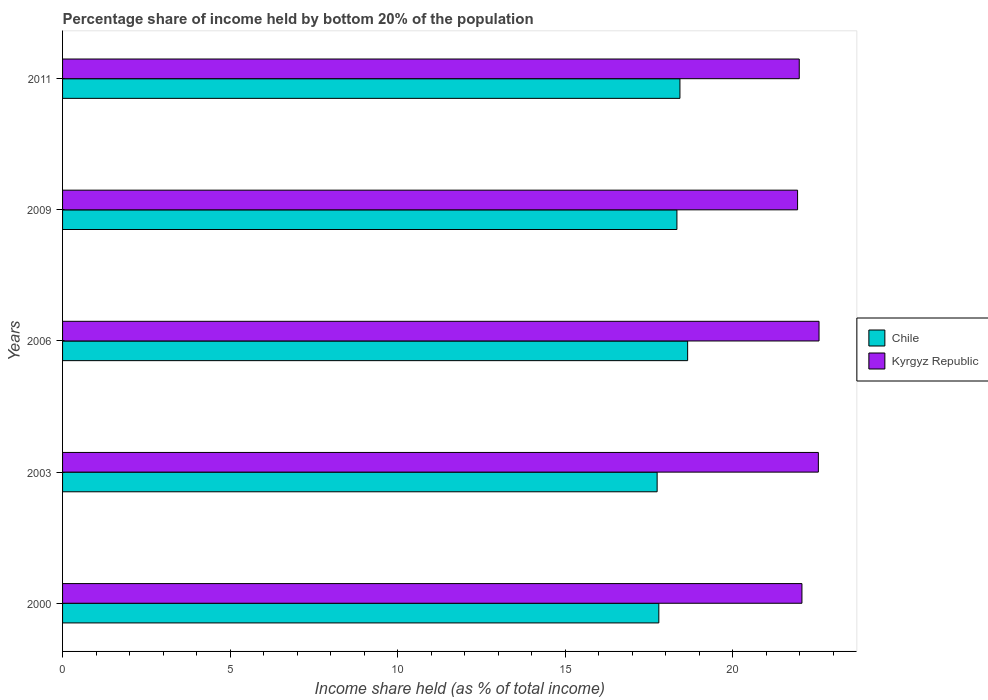Are the number of bars per tick equal to the number of legend labels?
Your answer should be compact. Yes. Are the number of bars on each tick of the Y-axis equal?
Your answer should be very brief. Yes. How many bars are there on the 3rd tick from the top?
Offer a terse response. 2. How many bars are there on the 2nd tick from the bottom?
Your answer should be compact. 2. What is the share of income held by bottom 20% of the population in Kyrgyz Republic in 2009?
Your answer should be very brief. 21.93. Across all years, what is the maximum share of income held by bottom 20% of the population in Chile?
Ensure brevity in your answer.  18.65. Across all years, what is the minimum share of income held by bottom 20% of the population in Kyrgyz Republic?
Your answer should be compact. 21.93. In which year was the share of income held by bottom 20% of the population in Kyrgyz Republic maximum?
Your answer should be compact. 2006. In which year was the share of income held by bottom 20% of the population in Chile minimum?
Your answer should be very brief. 2003. What is the total share of income held by bottom 20% of the population in Kyrgyz Republic in the graph?
Your answer should be compact. 111.09. What is the difference between the share of income held by bottom 20% of the population in Kyrgyz Republic in 2003 and that in 2011?
Your response must be concise. 0.57. What is the difference between the share of income held by bottom 20% of the population in Chile in 2000 and the share of income held by bottom 20% of the population in Kyrgyz Republic in 2003?
Make the answer very short. -4.76. What is the average share of income held by bottom 20% of the population in Kyrgyz Republic per year?
Ensure brevity in your answer.  22.22. In the year 2009, what is the difference between the share of income held by bottom 20% of the population in Chile and share of income held by bottom 20% of the population in Kyrgyz Republic?
Your answer should be compact. -3.6. In how many years, is the share of income held by bottom 20% of the population in Chile greater than 11 %?
Your response must be concise. 5. What is the ratio of the share of income held by bottom 20% of the population in Chile in 2006 to that in 2009?
Provide a short and direct response. 1.02. What is the difference between the highest and the second highest share of income held by bottom 20% of the population in Chile?
Ensure brevity in your answer.  0.23. What is the difference between the highest and the lowest share of income held by bottom 20% of the population in Chile?
Offer a terse response. 0.91. In how many years, is the share of income held by bottom 20% of the population in Kyrgyz Republic greater than the average share of income held by bottom 20% of the population in Kyrgyz Republic taken over all years?
Your answer should be very brief. 2. Is the sum of the share of income held by bottom 20% of the population in Chile in 2009 and 2011 greater than the maximum share of income held by bottom 20% of the population in Kyrgyz Republic across all years?
Offer a very short reply. Yes. What does the 1st bar from the top in 2011 represents?
Ensure brevity in your answer.  Kyrgyz Republic. Are all the bars in the graph horizontal?
Give a very brief answer. Yes. Are the values on the major ticks of X-axis written in scientific E-notation?
Offer a very short reply. No. How many legend labels are there?
Give a very brief answer. 2. What is the title of the graph?
Your answer should be very brief. Percentage share of income held by bottom 20% of the population. Does "Singapore" appear as one of the legend labels in the graph?
Ensure brevity in your answer.  No. What is the label or title of the X-axis?
Your answer should be very brief. Income share held (as % of total income). What is the Income share held (as % of total income) in Chile in 2000?
Make the answer very short. 17.79. What is the Income share held (as % of total income) in Kyrgyz Republic in 2000?
Give a very brief answer. 22.06. What is the Income share held (as % of total income) of Chile in 2003?
Your response must be concise. 17.74. What is the Income share held (as % of total income) in Kyrgyz Republic in 2003?
Offer a terse response. 22.55. What is the Income share held (as % of total income) in Chile in 2006?
Offer a very short reply. 18.65. What is the Income share held (as % of total income) of Kyrgyz Republic in 2006?
Your answer should be compact. 22.57. What is the Income share held (as % of total income) of Chile in 2009?
Make the answer very short. 18.33. What is the Income share held (as % of total income) in Kyrgyz Republic in 2009?
Make the answer very short. 21.93. What is the Income share held (as % of total income) in Chile in 2011?
Your response must be concise. 18.42. What is the Income share held (as % of total income) of Kyrgyz Republic in 2011?
Offer a very short reply. 21.98. Across all years, what is the maximum Income share held (as % of total income) in Chile?
Your answer should be compact. 18.65. Across all years, what is the maximum Income share held (as % of total income) of Kyrgyz Republic?
Ensure brevity in your answer.  22.57. Across all years, what is the minimum Income share held (as % of total income) of Chile?
Offer a very short reply. 17.74. Across all years, what is the minimum Income share held (as % of total income) in Kyrgyz Republic?
Keep it short and to the point. 21.93. What is the total Income share held (as % of total income) in Chile in the graph?
Offer a very short reply. 90.93. What is the total Income share held (as % of total income) in Kyrgyz Republic in the graph?
Offer a very short reply. 111.09. What is the difference between the Income share held (as % of total income) of Chile in 2000 and that in 2003?
Ensure brevity in your answer.  0.05. What is the difference between the Income share held (as % of total income) of Kyrgyz Republic in 2000 and that in 2003?
Provide a short and direct response. -0.49. What is the difference between the Income share held (as % of total income) in Chile in 2000 and that in 2006?
Offer a terse response. -0.86. What is the difference between the Income share held (as % of total income) of Kyrgyz Republic in 2000 and that in 2006?
Offer a very short reply. -0.51. What is the difference between the Income share held (as % of total income) of Chile in 2000 and that in 2009?
Your answer should be very brief. -0.54. What is the difference between the Income share held (as % of total income) of Kyrgyz Republic in 2000 and that in 2009?
Your response must be concise. 0.13. What is the difference between the Income share held (as % of total income) in Chile in 2000 and that in 2011?
Provide a short and direct response. -0.63. What is the difference between the Income share held (as % of total income) in Kyrgyz Republic in 2000 and that in 2011?
Offer a very short reply. 0.08. What is the difference between the Income share held (as % of total income) of Chile in 2003 and that in 2006?
Keep it short and to the point. -0.91. What is the difference between the Income share held (as % of total income) in Kyrgyz Republic in 2003 and that in 2006?
Ensure brevity in your answer.  -0.02. What is the difference between the Income share held (as % of total income) in Chile in 2003 and that in 2009?
Give a very brief answer. -0.59. What is the difference between the Income share held (as % of total income) in Kyrgyz Republic in 2003 and that in 2009?
Your answer should be compact. 0.62. What is the difference between the Income share held (as % of total income) of Chile in 2003 and that in 2011?
Make the answer very short. -0.68. What is the difference between the Income share held (as % of total income) in Kyrgyz Republic in 2003 and that in 2011?
Your response must be concise. 0.57. What is the difference between the Income share held (as % of total income) of Chile in 2006 and that in 2009?
Make the answer very short. 0.32. What is the difference between the Income share held (as % of total income) in Kyrgyz Republic in 2006 and that in 2009?
Offer a terse response. 0.64. What is the difference between the Income share held (as % of total income) in Chile in 2006 and that in 2011?
Your answer should be very brief. 0.23. What is the difference between the Income share held (as % of total income) in Kyrgyz Republic in 2006 and that in 2011?
Give a very brief answer. 0.59. What is the difference between the Income share held (as % of total income) of Chile in 2009 and that in 2011?
Keep it short and to the point. -0.09. What is the difference between the Income share held (as % of total income) in Chile in 2000 and the Income share held (as % of total income) in Kyrgyz Republic in 2003?
Offer a very short reply. -4.76. What is the difference between the Income share held (as % of total income) of Chile in 2000 and the Income share held (as % of total income) of Kyrgyz Republic in 2006?
Provide a short and direct response. -4.78. What is the difference between the Income share held (as % of total income) in Chile in 2000 and the Income share held (as % of total income) in Kyrgyz Republic in 2009?
Keep it short and to the point. -4.14. What is the difference between the Income share held (as % of total income) in Chile in 2000 and the Income share held (as % of total income) in Kyrgyz Republic in 2011?
Offer a terse response. -4.19. What is the difference between the Income share held (as % of total income) of Chile in 2003 and the Income share held (as % of total income) of Kyrgyz Republic in 2006?
Provide a short and direct response. -4.83. What is the difference between the Income share held (as % of total income) in Chile in 2003 and the Income share held (as % of total income) in Kyrgyz Republic in 2009?
Provide a succinct answer. -4.19. What is the difference between the Income share held (as % of total income) of Chile in 2003 and the Income share held (as % of total income) of Kyrgyz Republic in 2011?
Your answer should be compact. -4.24. What is the difference between the Income share held (as % of total income) in Chile in 2006 and the Income share held (as % of total income) in Kyrgyz Republic in 2009?
Offer a terse response. -3.28. What is the difference between the Income share held (as % of total income) in Chile in 2006 and the Income share held (as % of total income) in Kyrgyz Republic in 2011?
Give a very brief answer. -3.33. What is the difference between the Income share held (as % of total income) in Chile in 2009 and the Income share held (as % of total income) in Kyrgyz Republic in 2011?
Your response must be concise. -3.65. What is the average Income share held (as % of total income) in Chile per year?
Your answer should be very brief. 18.19. What is the average Income share held (as % of total income) of Kyrgyz Republic per year?
Offer a very short reply. 22.22. In the year 2000, what is the difference between the Income share held (as % of total income) of Chile and Income share held (as % of total income) of Kyrgyz Republic?
Offer a terse response. -4.27. In the year 2003, what is the difference between the Income share held (as % of total income) in Chile and Income share held (as % of total income) in Kyrgyz Republic?
Offer a very short reply. -4.81. In the year 2006, what is the difference between the Income share held (as % of total income) in Chile and Income share held (as % of total income) in Kyrgyz Republic?
Offer a very short reply. -3.92. In the year 2011, what is the difference between the Income share held (as % of total income) in Chile and Income share held (as % of total income) in Kyrgyz Republic?
Provide a short and direct response. -3.56. What is the ratio of the Income share held (as % of total income) in Kyrgyz Republic in 2000 to that in 2003?
Offer a very short reply. 0.98. What is the ratio of the Income share held (as % of total income) in Chile in 2000 to that in 2006?
Your response must be concise. 0.95. What is the ratio of the Income share held (as % of total income) in Kyrgyz Republic in 2000 to that in 2006?
Make the answer very short. 0.98. What is the ratio of the Income share held (as % of total income) in Chile in 2000 to that in 2009?
Make the answer very short. 0.97. What is the ratio of the Income share held (as % of total income) in Kyrgyz Republic in 2000 to that in 2009?
Give a very brief answer. 1.01. What is the ratio of the Income share held (as % of total income) of Chile in 2000 to that in 2011?
Ensure brevity in your answer.  0.97. What is the ratio of the Income share held (as % of total income) of Chile in 2003 to that in 2006?
Your answer should be very brief. 0.95. What is the ratio of the Income share held (as % of total income) of Kyrgyz Republic in 2003 to that in 2006?
Ensure brevity in your answer.  1. What is the ratio of the Income share held (as % of total income) of Chile in 2003 to that in 2009?
Your answer should be compact. 0.97. What is the ratio of the Income share held (as % of total income) of Kyrgyz Republic in 2003 to that in 2009?
Offer a terse response. 1.03. What is the ratio of the Income share held (as % of total income) of Chile in 2003 to that in 2011?
Offer a terse response. 0.96. What is the ratio of the Income share held (as % of total income) in Kyrgyz Republic in 2003 to that in 2011?
Keep it short and to the point. 1.03. What is the ratio of the Income share held (as % of total income) of Chile in 2006 to that in 2009?
Give a very brief answer. 1.02. What is the ratio of the Income share held (as % of total income) of Kyrgyz Republic in 2006 to that in 2009?
Give a very brief answer. 1.03. What is the ratio of the Income share held (as % of total income) of Chile in 2006 to that in 2011?
Offer a very short reply. 1.01. What is the ratio of the Income share held (as % of total income) of Kyrgyz Republic in 2006 to that in 2011?
Your answer should be compact. 1.03. What is the difference between the highest and the second highest Income share held (as % of total income) of Chile?
Keep it short and to the point. 0.23. What is the difference between the highest and the second highest Income share held (as % of total income) in Kyrgyz Republic?
Your answer should be very brief. 0.02. What is the difference between the highest and the lowest Income share held (as % of total income) of Chile?
Your answer should be very brief. 0.91. What is the difference between the highest and the lowest Income share held (as % of total income) of Kyrgyz Republic?
Offer a very short reply. 0.64. 